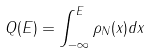<formula> <loc_0><loc_0><loc_500><loc_500>Q ( E ) = \int _ { - \infty } ^ { E } { \rho } _ { N } ( x ) d x</formula> 